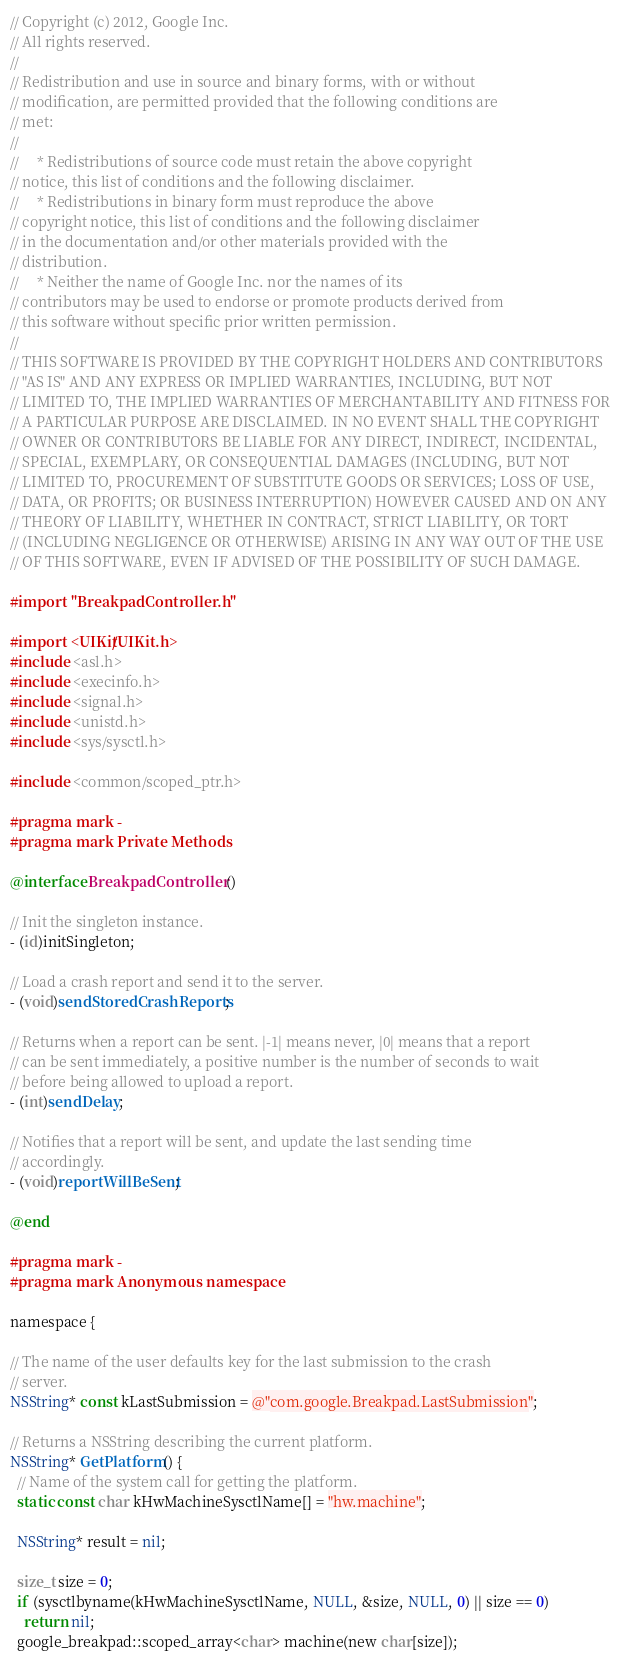<code> <loc_0><loc_0><loc_500><loc_500><_ObjectiveC_>// Copyright (c) 2012, Google Inc.
// All rights reserved.
//
// Redistribution and use in source and binary forms, with or without
// modification, are permitted provided that the following conditions are
// met:
//
//     * Redistributions of source code must retain the above copyright
// notice, this list of conditions and the following disclaimer.
//     * Redistributions in binary form must reproduce the above
// copyright notice, this list of conditions and the following disclaimer
// in the documentation and/or other materials provided with the
// distribution.
//     * Neither the name of Google Inc. nor the names of its
// contributors may be used to endorse or promote products derived from
// this software without specific prior written permission.
//
// THIS SOFTWARE IS PROVIDED BY THE COPYRIGHT HOLDERS AND CONTRIBUTORS
// "AS IS" AND ANY EXPRESS OR IMPLIED WARRANTIES, INCLUDING, BUT NOT
// LIMITED TO, THE IMPLIED WARRANTIES OF MERCHANTABILITY AND FITNESS FOR
// A PARTICULAR PURPOSE ARE DISCLAIMED. IN NO EVENT SHALL THE COPYRIGHT
// OWNER OR CONTRIBUTORS BE LIABLE FOR ANY DIRECT, INDIRECT, INCIDENTAL,
// SPECIAL, EXEMPLARY, OR CONSEQUENTIAL DAMAGES (INCLUDING, BUT NOT
// LIMITED TO, PROCUREMENT OF SUBSTITUTE GOODS OR SERVICES; LOSS OF USE,
// DATA, OR PROFITS; OR BUSINESS INTERRUPTION) HOWEVER CAUSED AND ON ANY
// THEORY OF LIABILITY, WHETHER IN CONTRACT, STRICT LIABILITY, OR TORT
// (INCLUDING NEGLIGENCE OR OTHERWISE) ARISING IN ANY WAY OUT OF THE USE
// OF THIS SOFTWARE, EVEN IF ADVISED OF THE POSSIBILITY OF SUCH DAMAGE.

#import "BreakpadController.h"

#import <UIKit/UIKit.h>
#include <asl.h>
#include <execinfo.h>
#include <signal.h>
#include <unistd.h>
#include <sys/sysctl.h>

#include <common/scoped_ptr.h>

#pragma mark -
#pragma mark Private Methods

@interface BreakpadController ()

// Init the singleton instance.
- (id)initSingleton;

// Load a crash report and send it to the server.
- (void)sendStoredCrashReports;

// Returns when a report can be sent. |-1| means never, |0| means that a report
// can be sent immediately, a positive number is the number of seconds to wait
// before being allowed to upload a report.
- (int)sendDelay;

// Notifies that a report will be sent, and update the last sending time
// accordingly.
- (void)reportWillBeSent;

@end

#pragma mark -
#pragma mark Anonymous namespace

namespace {

// The name of the user defaults key for the last submission to the crash
// server.
NSString* const kLastSubmission = @"com.google.Breakpad.LastSubmission";

// Returns a NSString describing the current platform.
NSString* GetPlatform() {
  // Name of the system call for getting the platform.
  static const char kHwMachineSysctlName[] = "hw.machine";

  NSString* result = nil;

  size_t size = 0;
  if (sysctlbyname(kHwMachineSysctlName, NULL, &size, NULL, 0) || size == 0)
    return nil;
  google_breakpad::scoped_array<char> machine(new char[size]);</code> 